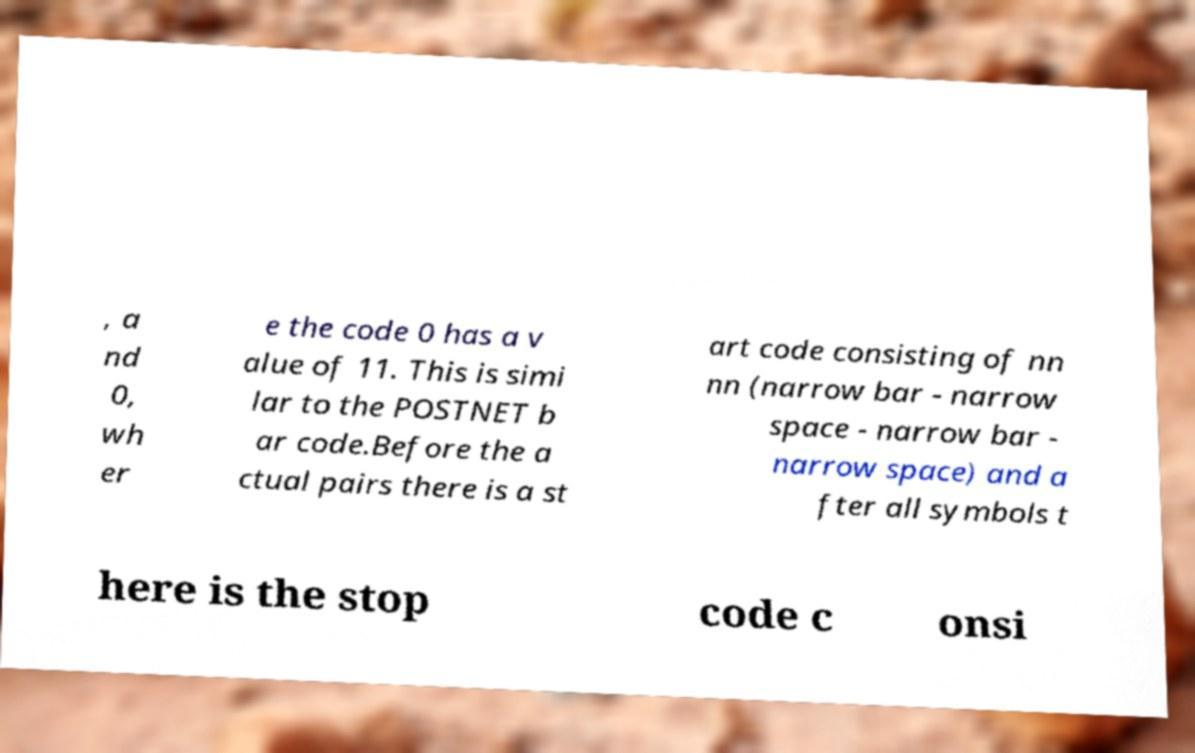Can you read and provide the text displayed in the image?This photo seems to have some interesting text. Can you extract and type it out for me? , a nd 0, wh er e the code 0 has a v alue of 11. This is simi lar to the POSTNET b ar code.Before the a ctual pairs there is a st art code consisting of nn nn (narrow bar - narrow space - narrow bar - narrow space) and a fter all symbols t here is the stop code c onsi 